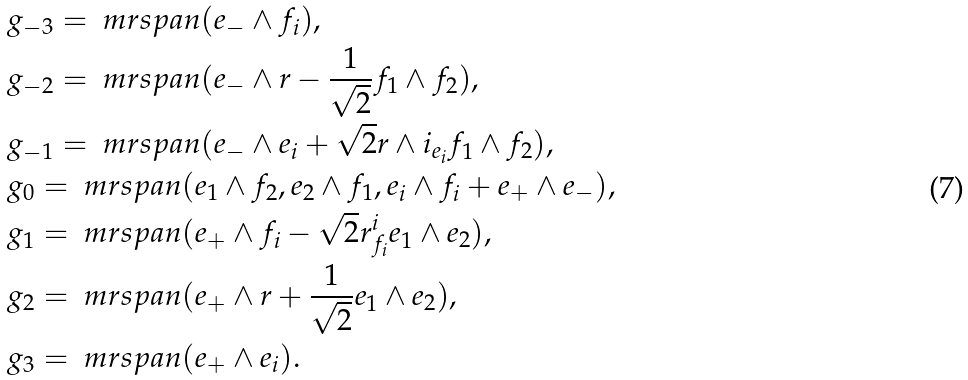<formula> <loc_0><loc_0><loc_500><loc_500>& \ g _ { - 3 } = \ m r { s p a n } ( e _ { - } \wedge f _ { i } ) , \\ & \ g _ { - 2 } = \ m r { s p a n } ( e _ { - } \wedge r - \frac { 1 } { \sqrt { 2 } } f _ { 1 } \wedge f _ { 2 } ) , \\ & \ g _ { - 1 } = \ m r { s p a n } ( e _ { - } \wedge e _ { i } + \sqrt { 2 } r \wedge i _ { e _ { i } } f _ { 1 } \wedge f _ { 2 } ) , \\ & \ g _ { 0 } = \ m r { s p a n } ( e _ { 1 } \wedge f _ { 2 } , e _ { 2 } \wedge f _ { 1 } , e _ { i } \wedge f _ { i } + e _ { + } \wedge e _ { - } ) , \\ & \ g _ { 1 } = \ m r { s p a n } ( e _ { + } \wedge f _ { i } - \sqrt { 2 } r ^ { i } _ { f _ { i } } e _ { 1 } \wedge e _ { 2 } ) , \\ & \ g _ { 2 } = \ m r { s p a n } ( e _ { + } \wedge r + \frac { 1 } { \sqrt { 2 } } e _ { 1 } \wedge e _ { 2 } ) , \\ & \ g _ { 3 } = \ m r { s p a n } ( e _ { + } \wedge e _ { i } ) .</formula> 